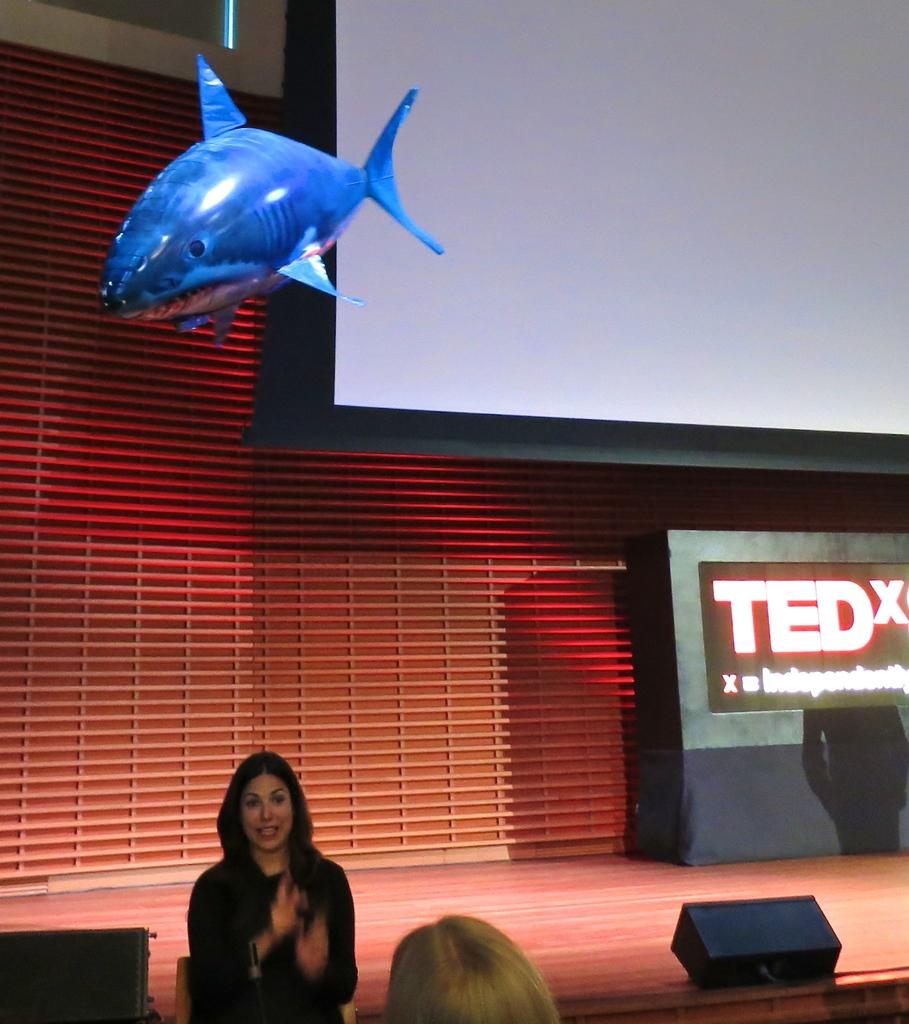How many people are present in the image? There are two people in the image. What is the setting of the image? There is a stage in the image, which suggests a performance or event. What equipment is present in the image? There are speakers and screens in the image, which are commonly used for amplifying sound and displaying visuals. What additional item can be seen in the image? There is an inflatable shark in the image, which is an unusual and unexpected detail. What type of coat is the person wearing in the image? There is no coat visible in the image; the people are not wearing any outerwear. Can you see any birds flying in the image? There are no birds present in the image; the focus is on the people, stage, and other equipment. 